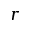Convert formula to latex. <formula><loc_0><loc_0><loc_500><loc_500>r</formula> 